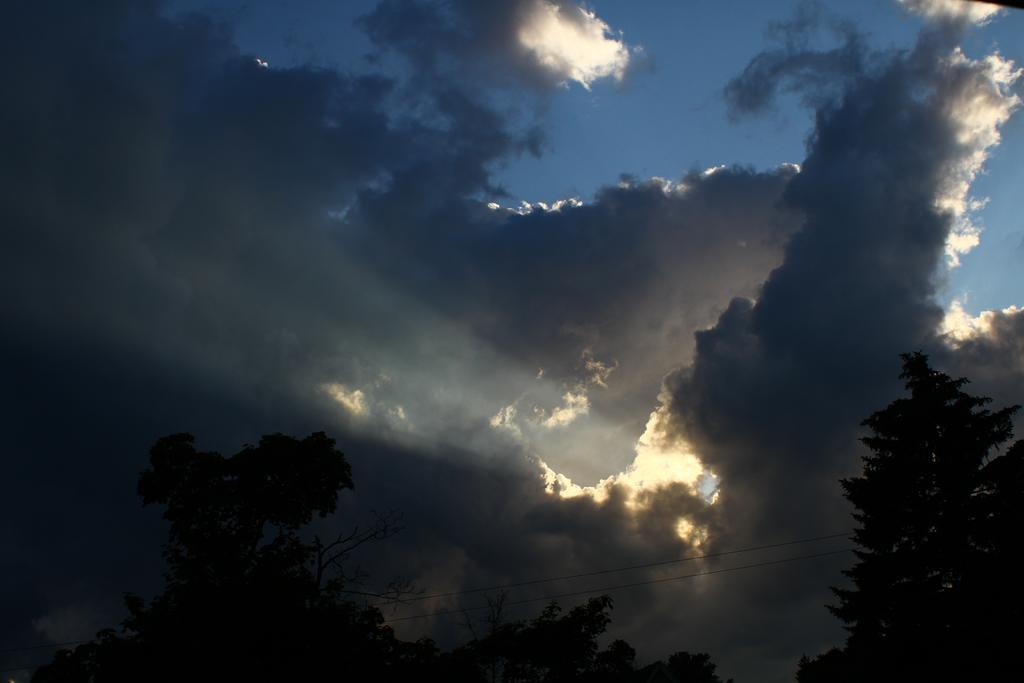What type of vegetation can be seen in the image? There are trees in the image. What is the condition of the sky in the image? The sky is cloudy in the image. What type of steel is used to construct the shape of the servant in the image? There is no servant or steel present in the image; it features trees and a cloudy sky. 